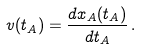<formula> <loc_0><loc_0><loc_500><loc_500>v ( t _ { A } ) = \frac { d x _ { A } ( t _ { A } ) } { d t _ { A } } \, .</formula> 